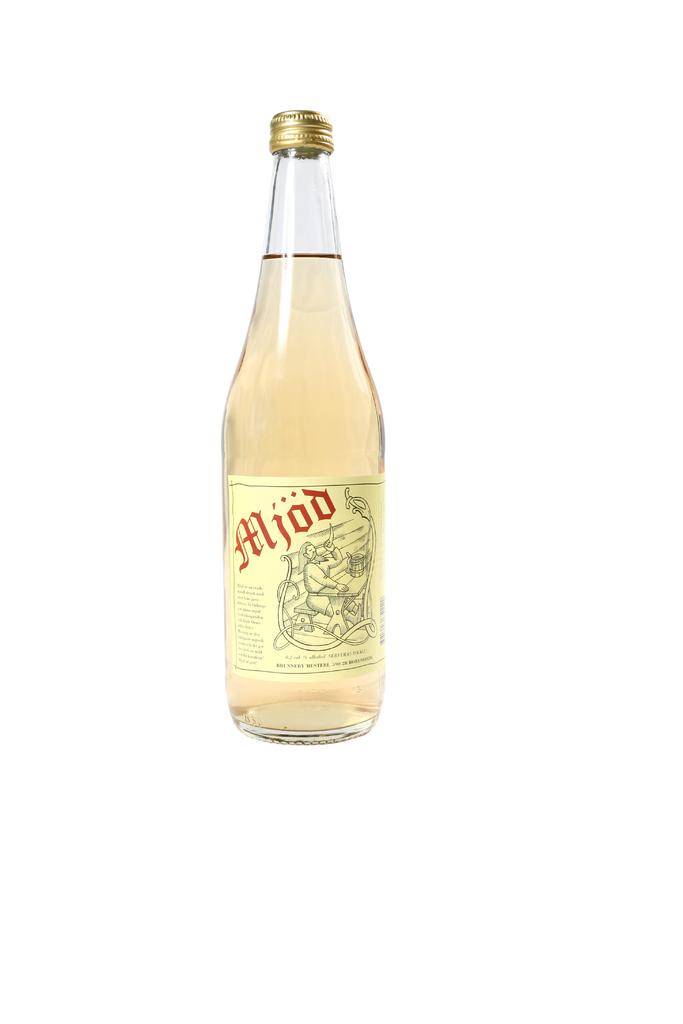What is the name of the drink?
Your response must be concise. Mjod. What brand is the drink?
Offer a terse response. Mjod. 